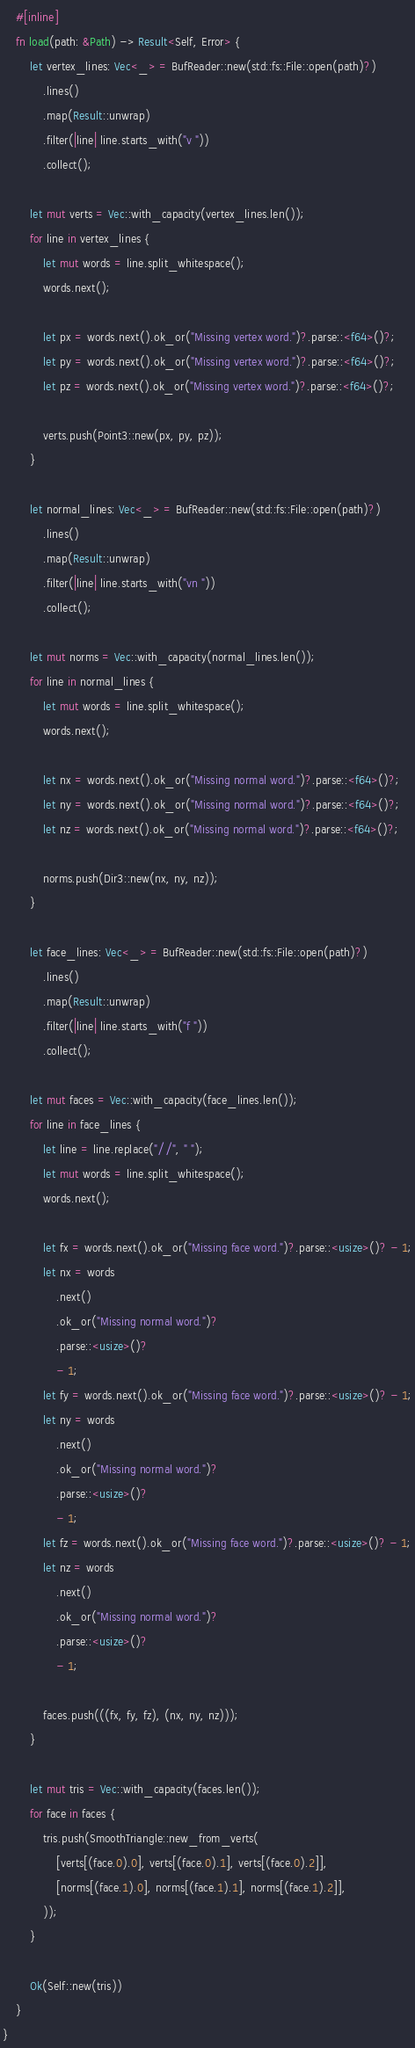<code> <loc_0><loc_0><loc_500><loc_500><_Rust_>    #[inline]
    fn load(path: &Path) -> Result<Self, Error> {
        let vertex_lines: Vec<_> = BufReader::new(std::fs::File::open(path)?)
            .lines()
            .map(Result::unwrap)
            .filter(|line| line.starts_with("v "))
            .collect();

        let mut verts = Vec::with_capacity(vertex_lines.len());
        for line in vertex_lines {
            let mut words = line.split_whitespace();
            words.next();

            let px = words.next().ok_or("Missing vertex word.")?.parse::<f64>()?;
            let py = words.next().ok_or("Missing vertex word.")?.parse::<f64>()?;
            let pz = words.next().ok_or("Missing vertex word.")?.parse::<f64>()?;

            verts.push(Point3::new(px, py, pz));
        }

        let normal_lines: Vec<_> = BufReader::new(std::fs::File::open(path)?)
            .lines()
            .map(Result::unwrap)
            .filter(|line| line.starts_with("vn "))
            .collect();

        let mut norms = Vec::with_capacity(normal_lines.len());
        for line in normal_lines {
            let mut words = line.split_whitespace();
            words.next();

            let nx = words.next().ok_or("Missing normal word.")?.parse::<f64>()?;
            let ny = words.next().ok_or("Missing normal word.")?.parse::<f64>()?;
            let nz = words.next().ok_or("Missing normal word.")?.parse::<f64>()?;

            norms.push(Dir3::new(nx, ny, nz));
        }

        let face_lines: Vec<_> = BufReader::new(std::fs::File::open(path)?)
            .lines()
            .map(Result::unwrap)
            .filter(|line| line.starts_with("f "))
            .collect();

        let mut faces = Vec::with_capacity(face_lines.len());
        for line in face_lines {
            let line = line.replace("//", " ");
            let mut words = line.split_whitespace();
            words.next();

            let fx = words.next().ok_or("Missing face word.")?.parse::<usize>()? - 1;
            let nx = words
                .next()
                .ok_or("Missing normal word.")?
                .parse::<usize>()?
                - 1;
            let fy = words.next().ok_or("Missing face word.")?.parse::<usize>()? - 1;
            let ny = words
                .next()
                .ok_or("Missing normal word.")?
                .parse::<usize>()?
                - 1;
            let fz = words.next().ok_or("Missing face word.")?.parse::<usize>()? - 1;
            let nz = words
                .next()
                .ok_or("Missing normal word.")?
                .parse::<usize>()?
                - 1;

            faces.push(((fx, fy, fz), (nx, ny, nz)));
        }

        let mut tris = Vec::with_capacity(faces.len());
        for face in faces {
            tris.push(SmoothTriangle::new_from_verts(
                [verts[(face.0).0], verts[(face.0).1], verts[(face.0).2]],
                [norms[(face.1).0], norms[(face.1).1], norms[(face.1).2]],
            ));
        }

        Ok(Self::new(tris))
    }
}
</code> 